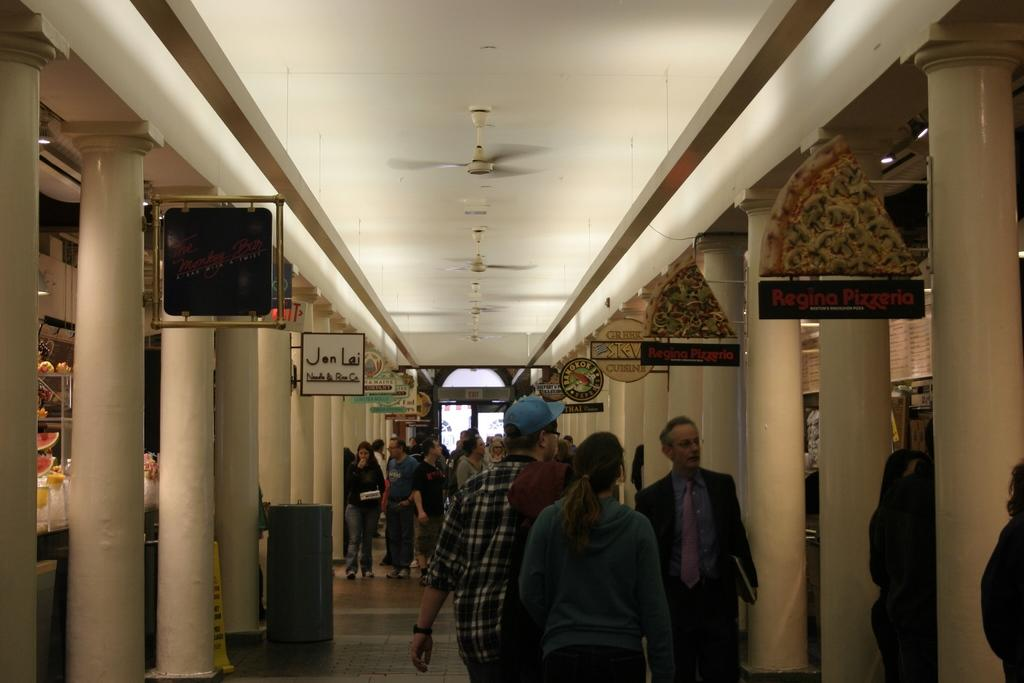What are the people in the image doing? The people in the image are walking. What architectural features can be seen in the image? There are pillars in the image. What objects are present in the image that might be used for displaying or storing items? There are boards and racks in the image. Where is the bin located in the image? The bin is on the left side of the image. What type of pump is being used by the uncle in the image? There is no pump or uncle present in the image. What type of linen is being displayed on the racks in the image? There is no linen visible on the racks in the image. 